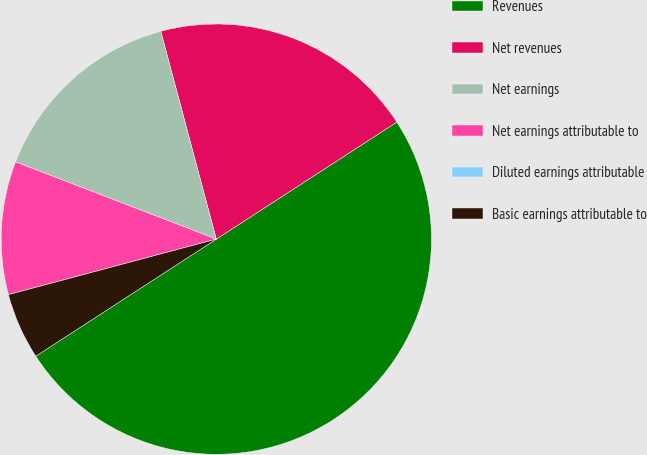Convert chart to OTSL. <chart><loc_0><loc_0><loc_500><loc_500><pie_chart><fcel>Revenues<fcel>Net revenues<fcel>Net earnings<fcel>Net earnings attributable to<fcel>Diluted earnings attributable<fcel>Basic earnings attributable to<nl><fcel>50.0%<fcel>20.0%<fcel>15.0%<fcel>10.0%<fcel>0.0%<fcel>5.0%<nl></chart> 